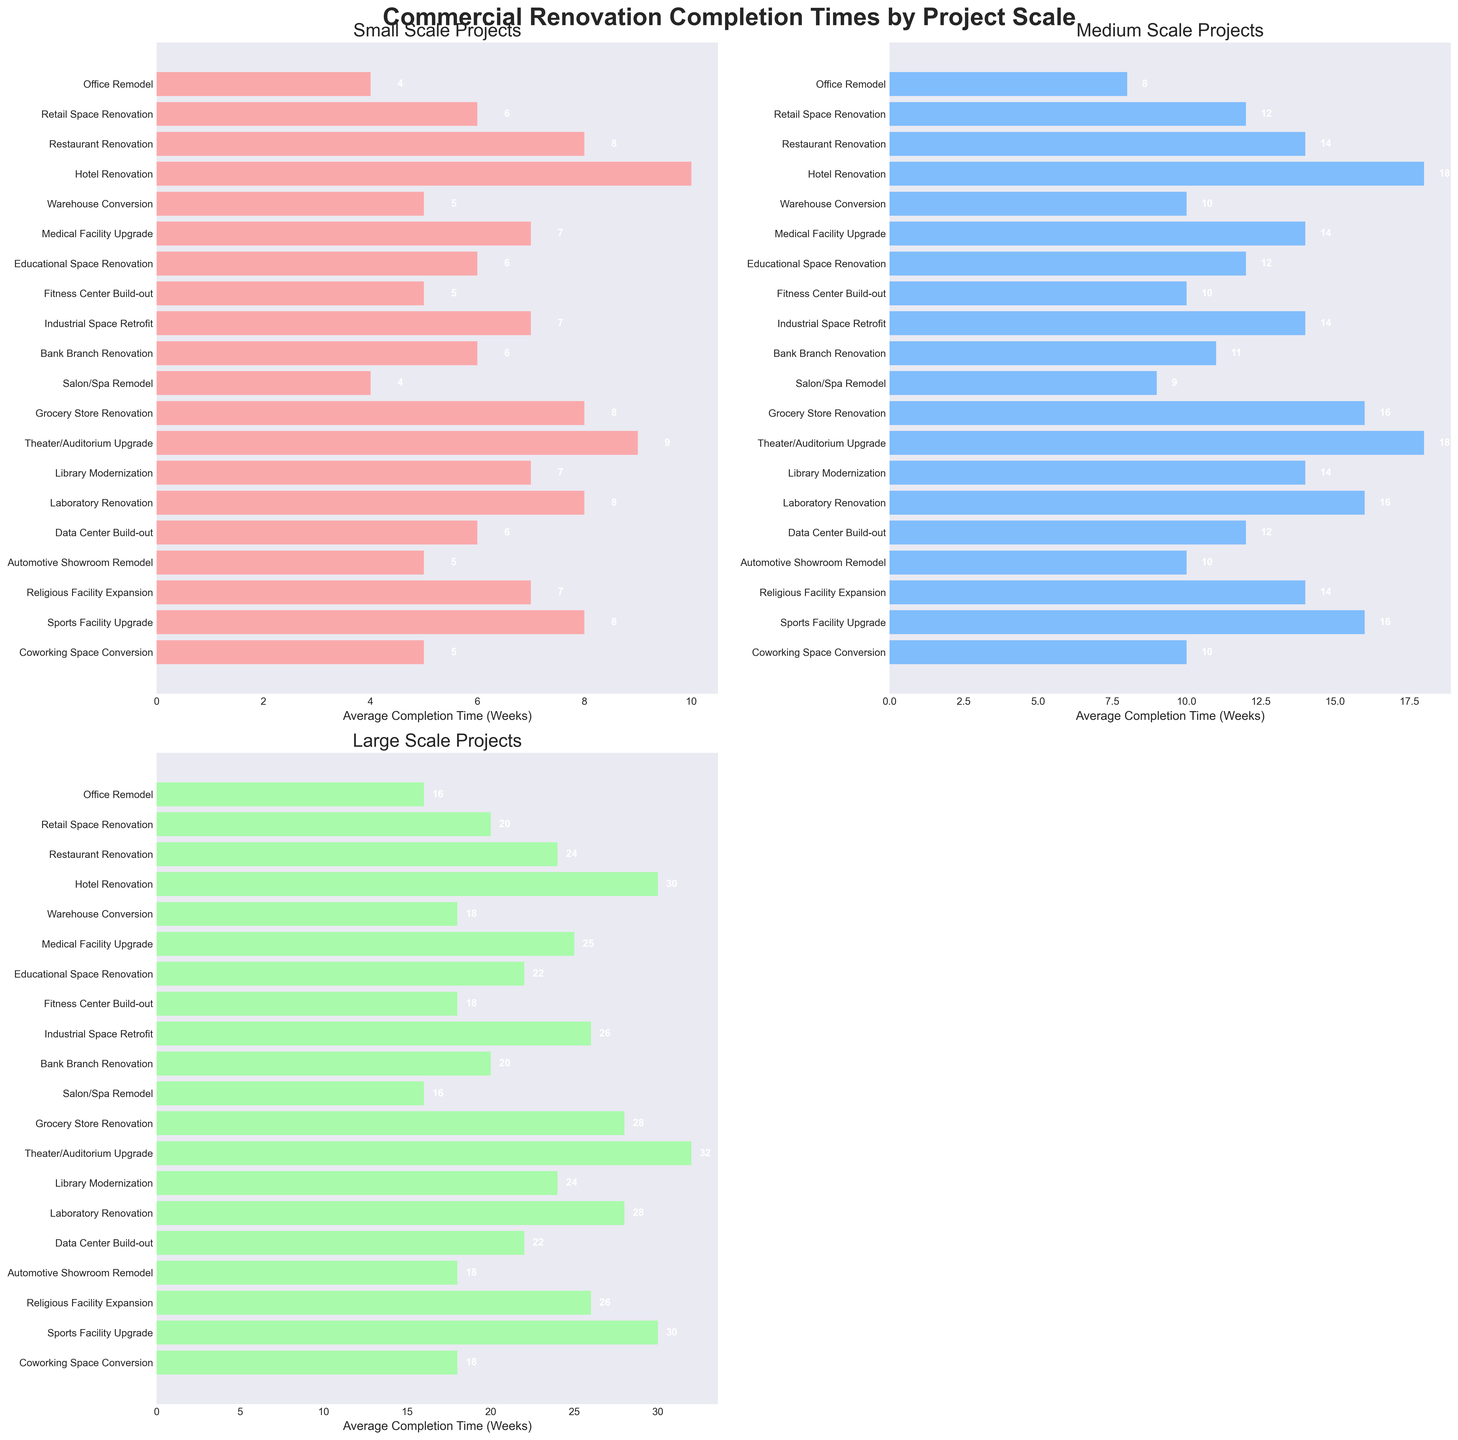What's the average completion time of Office Remodel projects across all scales? In the figure, each category shows the average completion times for Small, Medium, and Large scales. For Office Remodel, the times are 4, 8, and 16 weeks respectively. Adding these values gives 4 + 8 + 16 = 28 weeks. Dividing by the number of scales (3) gives 28/3 ≈ 9.33 weeks.
Answer: 9.33 weeks Which project type has the longest Large Scale completion time? In the Large Scale subplot, we need to look at the bar with the maximum length. The longest Large Scale completion time is 32 weeks for Theater/Auditorium Upgrade.
Answer: Theater/Auditorium Upgrade Do Restaurant Renovations take more time on average than Retail Space Renovations? To compare, average the times for both project types across all scales and compare. Restaurant Renovation: (8 + 14 + 24)/3 = 46/3 ≈ 15.33 weeks. Retail Space Renovation: (6 + 12 + 20)/3 = 38/3 ≈ 12.67 weeks. Since 15.33 > 12.67, Restaurant Renovations take more time on average.
Answer: Yes How much longer does a large scale Grocery Store Renovation take compared to a small scale one? In the figure, the completion times for Grocery Store Renovation are 8 weeks (small scale) and 28 weeks (large scale). The difference is 28 - 8 = 20 weeks.
Answer: 20 weeks What is the median completion time for Small Scale projects when grouped by project type? Arrange the small scale completion times in ascending order, then find the middle value. The values are: 4, 4, 5, 5, 5, 6, 6, 6, 7, 7, 7, 7, 8, 8, 8, 8, 9, 9, 10. The median is the 10th value, which is 7.
Answer: 7 weeks Are there any project types where the Medium Scale completion time is equal to the Large Scale completion time? In the figure, look for project types where the Medium and Large scales have the same bar lengths. There are no such project types as each Medium Scale time is less than its corresponding Large Scale time.
Answer: No Which project type has the shortest Small Scale completion time, and what is it? In the Small Scale subplot, the shortest bar corresponds to Office Remodel and Salon/Spa Remodel, both with a completion time of 4 weeks.
Answer: Office Remodel and Salon/Spa Remodel, 4 weeks Between Warehouse Conversion and Medical Facility Upgrade, which has a longer average completion time across all scales? Calculate the average for each. Warehouse Conversion: (5 + 10 + 18)/3 = 33/3 = 11 weeks. Medical Facility Upgrade: (7 + 14 + 25)/3 = 46/3 ≈ 15.33 weeks. Since 15.33 > 11, Medical Facility Upgrade takes longer.
Answer: Medical Facility Upgrade 